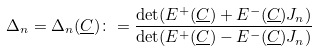Convert formula to latex. <formula><loc_0><loc_0><loc_500><loc_500>\Delta _ { n } = \Delta _ { n } ( \underline { C } ) \colon = \frac { \det ( E ^ { + } ( \underline { C } ) + E ^ { - } ( \underline { C } ) J _ { n } ) } { \det ( E ^ { + } ( \underline { C } ) - E ^ { - } ( \underline { C } ) J _ { n } ) }</formula> 